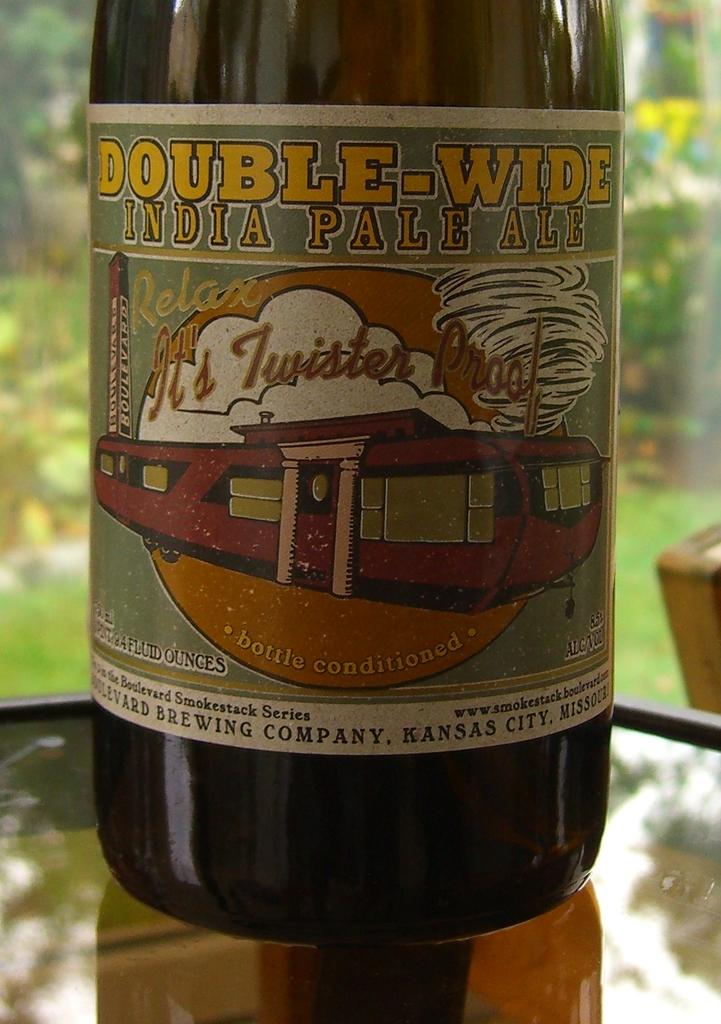Is this double-wide?
Your response must be concise. Yes. What type of beer is this?
Give a very brief answer. India pale ale. 